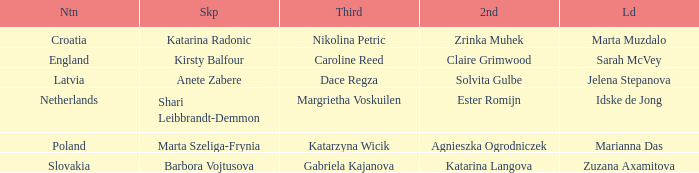Which lead has Kirsty Balfour as second? Sarah McVey. 